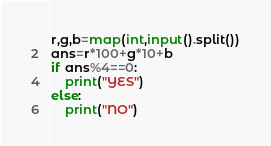<code> <loc_0><loc_0><loc_500><loc_500><_Python_>r,g,b=map(int,input().split())
ans=r*100+g*10+b
if ans%4==0:
    print("YES")
else:
    print("NO")
</code> 